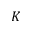<formula> <loc_0><loc_0><loc_500><loc_500>K</formula> 